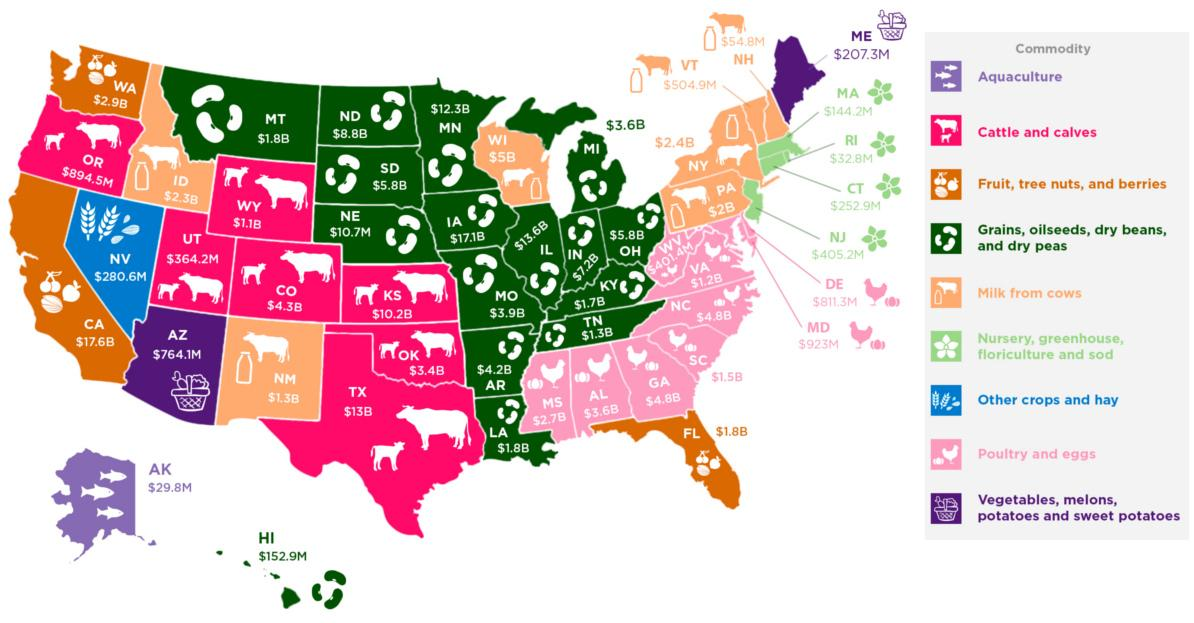Identify some key points in this picture. The rate of commodity Aquaculture in the state of Alaska was $29.8 million in 2020. In the United States, cattle and calves are present in a certain number of states. Trees, nuts, fruits, and berries are located in a total of three states. In the state of Nevada, other crops and hay are present. In the state of New Mexico, the current rate of the commodity milk is valued at $1.3 billion. 